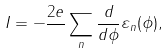<formula> <loc_0><loc_0><loc_500><loc_500>I = - \frac { 2 e } { } \sum _ { n } \frac { d } { d \phi } \varepsilon _ { n } ( \phi ) ,</formula> 